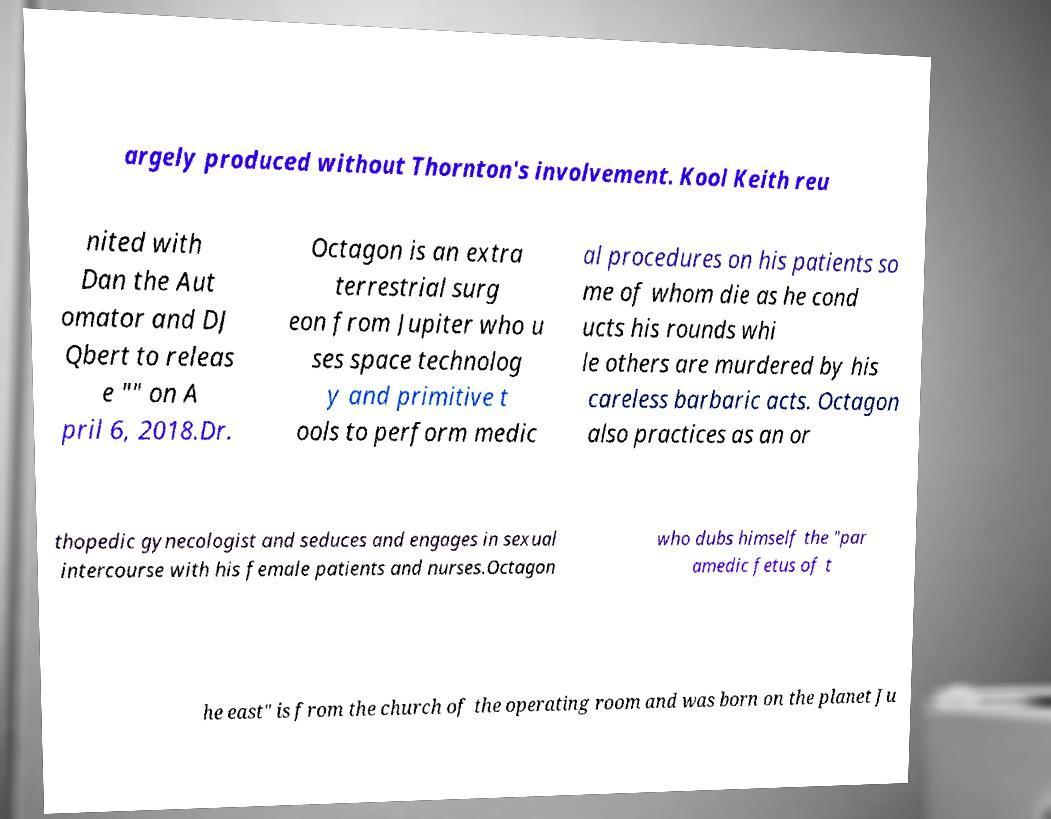For documentation purposes, I need the text within this image transcribed. Could you provide that? argely produced without Thornton's involvement. Kool Keith reu nited with Dan the Aut omator and DJ Qbert to releas e "" on A pril 6, 2018.Dr. Octagon is an extra terrestrial surg eon from Jupiter who u ses space technolog y and primitive t ools to perform medic al procedures on his patients so me of whom die as he cond ucts his rounds whi le others are murdered by his careless barbaric acts. Octagon also practices as an or thopedic gynecologist and seduces and engages in sexual intercourse with his female patients and nurses.Octagon who dubs himself the "par amedic fetus of t he east" is from the church of the operating room and was born on the planet Ju 